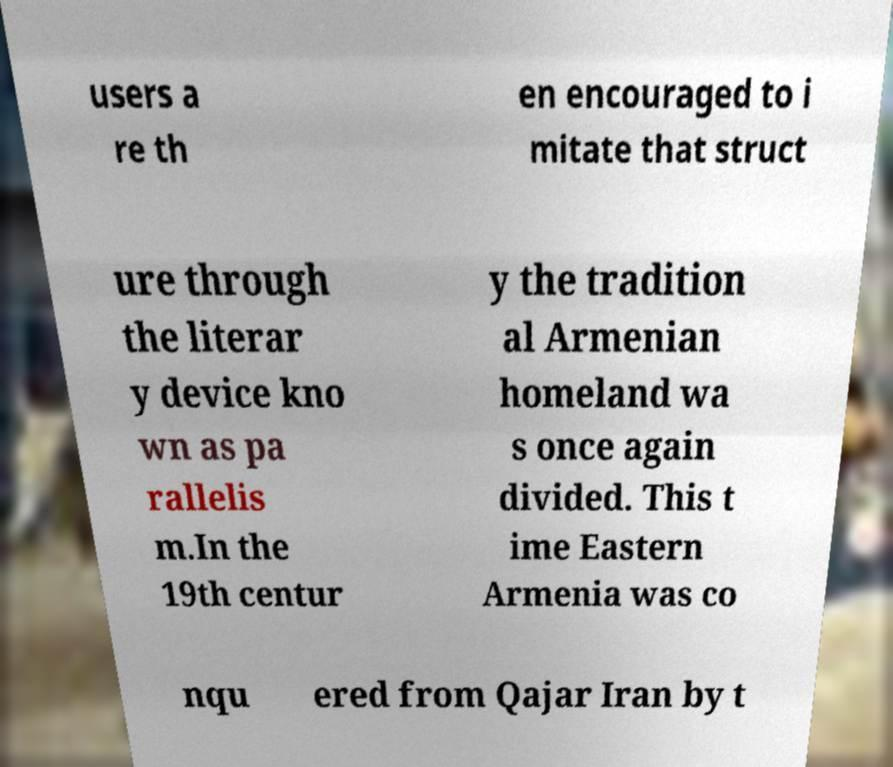There's text embedded in this image that I need extracted. Can you transcribe it verbatim? users a re th en encouraged to i mitate that struct ure through the literar y device kno wn as pa rallelis m.In the 19th centur y the tradition al Armenian homeland wa s once again divided. This t ime Eastern Armenia was co nqu ered from Qajar Iran by t 